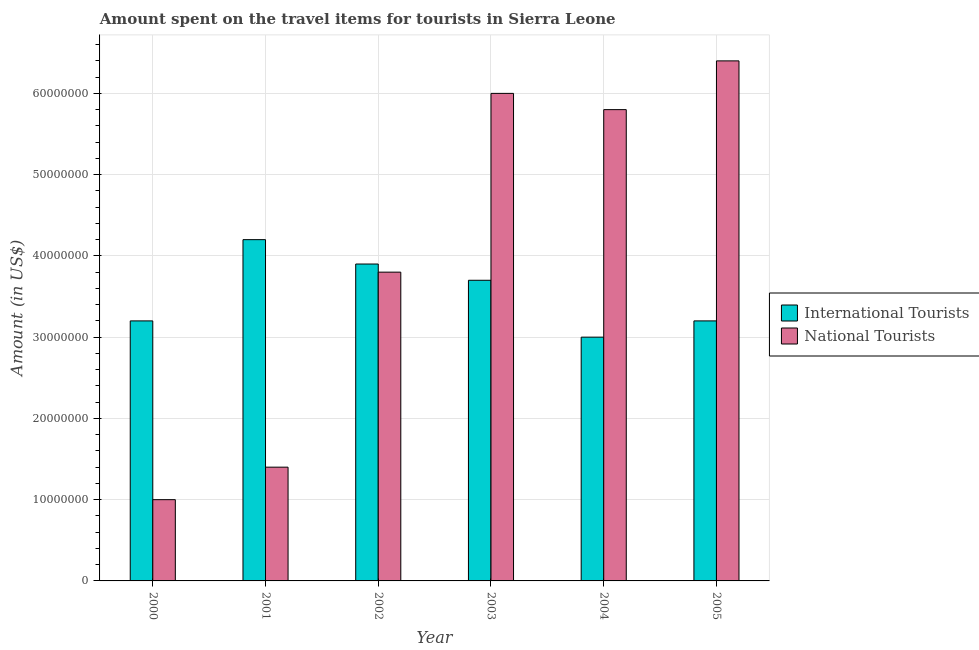Are the number of bars per tick equal to the number of legend labels?
Make the answer very short. Yes. How many bars are there on the 4th tick from the right?
Your answer should be compact. 2. What is the label of the 4th group of bars from the left?
Provide a succinct answer. 2003. What is the amount spent on travel items of national tourists in 2002?
Your answer should be very brief. 3.80e+07. Across all years, what is the maximum amount spent on travel items of international tourists?
Provide a short and direct response. 4.20e+07. Across all years, what is the minimum amount spent on travel items of international tourists?
Your answer should be very brief. 3.00e+07. In which year was the amount spent on travel items of national tourists maximum?
Provide a succinct answer. 2005. What is the total amount spent on travel items of international tourists in the graph?
Ensure brevity in your answer.  2.12e+08. What is the difference between the amount spent on travel items of national tourists in 2003 and that in 2005?
Offer a very short reply. -4.00e+06. What is the difference between the amount spent on travel items of national tourists in 2003 and the amount spent on travel items of international tourists in 2005?
Your response must be concise. -4.00e+06. What is the average amount spent on travel items of national tourists per year?
Offer a terse response. 4.07e+07. In how many years, is the amount spent on travel items of national tourists greater than 6000000 US$?
Provide a short and direct response. 6. What is the ratio of the amount spent on travel items of national tourists in 2001 to that in 2002?
Your response must be concise. 0.37. Is the amount spent on travel items of national tourists in 2003 less than that in 2004?
Offer a terse response. No. Is the difference between the amount spent on travel items of international tourists in 2000 and 2002 greater than the difference between the amount spent on travel items of national tourists in 2000 and 2002?
Ensure brevity in your answer.  No. What is the difference between the highest and the lowest amount spent on travel items of international tourists?
Offer a very short reply. 1.20e+07. In how many years, is the amount spent on travel items of international tourists greater than the average amount spent on travel items of international tourists taken over all years?
Give a very brief answer. 3. What does the 2nd bar from the left in 2003 represents?
Your response must be concise. National Tourists. What does the 1st bar from the right in 2001 represents?
Your answer should be very brief. National Tourists. How many bars are there?
Offer a very short reply. 12. Are all the bars in the graph horizontal?
Your answer should be compact. No. How many years are there in the graph?
Your answer should be compact. 6. What is the difference between two consecutive major ticks on the Y-axis?
Give a very brief answer. 1.00e+07. Are the values on the major ticks of Y-axis written in scientific E-notation?
Your answer should be very brief. No. Where does the legend appear in the graph?
Provide a succinct answer. Center right. How many legend labels are there?
Your answer should be compact. 2. What is the title of the graph?
Make the answer very short. Amount spent on the travel items for tourists in Sierra Leone. What is the Amount (in US$) of International Tourists in 2000?
Give a very brief answer. 3.20e+07. What is the Amount (in US$) of National Tourists in 2000?
Your answer should be compact. 1.00e+07. What is the Amount (in US$) in International Tourists in 2001?
Give a very brief answer. 4.20e+07. What is the Amount (in US$) in National Tourists in 2001?
Give a very brief answer. 1.40e+07. What is the Amount (in US$) of International Tourists in 2002?
Provide a succinct answer. 3.90e+07. What is the Amount (in US$) of National Tourists in 2002?
Ensure brevity in your answer.  3.80e+07. What is the Amount (in US$) in International Tourists in 2003?
Provide a succinct answer. 3.70e+07. What is the Amount (in US$) in National Tourists in 2003?
Your answer should be very brief. 6.00e+07. What is the Amount (in US$) in International Tourists in 2004?
Your answer should be compact. 3.00e+07. What is the Amount (in US$) in National Tourists in 2004?
Ensure brevity in your answer.  5.80e+07. What is the Amount (in US$) in International Tourists in 2005?
Give a very brief answer. 3.20e+07. What is the Amount (in US$) of National Tourists in 2005?
Your response must be concise. 6.40e+07. Across all years, what is the maximum Amount (in US$) of International Tourists?
Offer a terse response. 4.20e+07. Across all years, what is the maximum Amount (in US$) in National Tourists?
Provide a short and direct response. 6.40e+07. Across all years, what is the minimum Amount (in US$) of International Tourists?
Offer a terse response. 3.00e+07. Across all years, what is the minimum Amount (in US$) of National Tourists?
Ensure brevity in your answer.  1.00e+07. What is the total Amount (in US$) of International Tourists in the graph?
Your answer should be very brief. 2.12e+08. What is the total Amount (in US$) of National Tourists in the graph?
Provide a succinct answer. 2.44e+08. What is the difference between the Amount (in US$) of International Tourists in 2000 and that in 2001?
Your answer should be compact. -1.00e+07. What is the difference between the Amount (in US$) of International Tourists in 2000 and that in 2002?
Your answer should be compact. -7.00e+06. What is the difference between the Amount (in US$) in National Tourists in 2000 and that in 2002?
Ensure brevity in your answer.  -2.80e+07. What is the difference between the Amount (in US$) in International Tourists in 2000 and that in 2003?
Your answer should be very brief. -5.00e+06. What is the difference between the Amount (in US$) in National Tourists in 2000 and that in 2003?
Ensure brevity in your answer.  -5.00e+07. What is the difference between the Amount (in US$) in International Tourists in 2000 and that in 2004?
Your response must be concise. 2.00e+06. What is the difference between the Amount (in US$) of National Tourists in 2000 and that in 2004?
Give a very brief answer. -4.80e+07. What is the difference between the Amount (in US$) in National Tourists in 2000 and that in 2005?
Ensure brevity in your answer.  -5.40e+07. What is the difference between the Amount (in US$) of National Tourists in 2001 and that in 2002?
Give a very brief answer. -2.40e+07. What is the difference between the Amount (in US$) of International Tourists in 2001 and that in 2003?
Make the answer very short. 5.00e+06. What is the difference between the Amount (in US$) in National Tourists in 2001 and that in 2003?
Offer a terse response. -4.60e+07. What is the difference between the Amount (in US$) in International Tourists in 2001 and that in 2004?
Provide a short and direct response. 1.20e+07. What is the difference between the Amount (in US$) in National Tourists in 2001 and that in 2004?
Ensure brevity in your answer.  -4.40e+07. What is the difference between the Amount (in US$) of National Tourists in 2001 and that in 2005?
Offer a very short reply. -5.00e+07. What is the difference between the Amount (in US$) of National Tourists in 2002 and that in 2003?
Provide a short and direct response. -2.20e+07. What is the difference between the Amount (in US$) of International Tourists in 2002 and that in 2004?
Offer a very short reply. 9.00e+06. What is the difference between the Amount (in US$) of National Tourists in 2002 and that in 2004?
Provide a short and direct response. -2.00e+07. What is the difference between the Amount (in US$) in International Tourists in 2002 and that in 2005?
Offer a terse response. 7.00e+06. What is the difference between the Amount (in US$) of National Tourists in 2002 and that in 2005?
Provide a short and direct response. -2.60e+07. What is the difference between the Amount (in US$) in International Tourists in 2003 and that in 2004?
Give a very brief answer. 7.00e+06. What is the difference between the Amount (in US$) of National Tourists in 2003 and that in 2004?
Provide a short and direct response. 2.00e+06. What is the difference between the Amount (in US$) of International Tourists in 2004 and that in 2005?
Provide a succinct answer. -2.00e+06. What is the difference between the Amount (in US$) in National Tourists in 2004 and that in 2005?
Provide a succinct answer. -6.00e+06. What is the difference between the Amount (in US$) in International Tourists in 2000 and the Amount (in US$) in National Tourists in 2001?
Your answer should be very brief. 1.80e+07. What is the difference between the Amount (in US$) in International Tourists in 2000 and the Amount (in US$) in National Tourists in 2002?
Your answer should be very brief. -6.00e+06. What is the difference between the Amount (in US$) in International Tourists in 2000 and the Amount (in US$) in National Tourists in 2003?
Ensure brevity in your answer.  -2.80e+07. What is the difference between the Amount (in US$) in International Tourists in 2000 and the Amount (in US$) in National Tourists in 2004?
Provide a short and direct response. -2.60e+07. What is the difference between the Amount (in US$) of International Tourists in 2000 and the Amount (in US$) of National Tourists in 2005?
Provide a short and direct response. -3.20e+07. What is the difference between the Amount (in US$) in International Tourists in 2001 and the Amount (in US$) in National Tourists in 2002?
Offer a terse response. 4.00e+06. What is the difference between the Amount (in US$) of International Tourists in 2001 and the Amount (in US$) of National Tourists in 2003?
Your response must be concise. -1.80e+07. What is the difference between the Amount (in US$) of International Tourists in 2001 and the Amount (in US$) of National Tourists in 2004?
Make the answer very short. -1.60e+07. What is the difference between the Amount (in US$) in International Tourists in 2001 and the Amount (in US$) in National Tourists in 2005?
Provide a short and direct response. -2.20e+07. What is the difference between the Amount (in US$) of International Tourists in 2002 and the Amount (in US$) of National Tourists in 2003?
Ensure brevity in your answer.  -2.10e+07. What is the difference between the Amount (in US$) in International Tourists in 2002 and the Amount (in US$) in National Tourists in 2004?
Provide a succinct answer. -1.90e+07. What is the difference between the Amount (in US$) in International Tourists in 2002 and the Amount (in US$) in National Tourists in 2005?
Your response must be concise. -2.50e+07. What is the difference between the Amount (in US$) in International Tourists in 2003 and the Amount (in US$) in National Tourists in 2004?
Ensure brevity in your answer.  -2.10e+07. What is the difference between the Amount (in US$) of International Tourists in 2003 and the Amount (in US$) of National Tourists in 2005?
Give a very brief answer. -2.70e+07. What is the difference between the Amount (in US$) in International Tourists in 2004 and the Amount (in US$) in National Tourists in 2005?
Provide a succinct answer. -3.40e+07. What is the average Amount (in US$) of International Tourists per year?
Provide a short and direct response. 3.53e+07. What is the average Amount (in US$) of National Tourists per year?
Ensure brevity in your answer.  4.07e+07. In the year 2000, what is the difference between the Amount (in US$) in International Tourists and Amount (in US$) in National Tourists?
Offer a very short reply. 2.20e+07. In the year 2001, what is the difference between the Amount (in US$) in International Tourists and Amount (in US$) in National Tourists?
Your response must be concise. 2.80e+07. In the year 2002, what is the difference between the Amount (in US$) of International Tourists and Amount (in US$) of National Tourists?
Your answer should be compact. 1.00e+06. In the year 2003, what is the difference between the Amount (in US$) in International Tourists and Amount (in US$) in National Tourists?
Your answer should be very brief. -2.30e+07. In the year 2004, what is the difference between the Amount (in US$) of International Tourists and Amount (in US$) of National Tourists?
Give a very brief answer. -2.80e+07. In the year 2005, what is the difference between the Amount (in US$) of International Tourists and Amount (in US$) of National Tourists?
Provide a short and direct response. -3.20e+07. What is the ratio of the Amount (in US$) in International Tourists in 2000 to that in 2001?
Provide a short and direct response. 0.76. What is the ratio of the Amount (in US$) in National Tourists in 2000 to that in 2001?
Provide a short and direct response. 0.71. What is the ratio of the Amount (in US$) of International Tourists in 2000 to that in 2002?
Your response must be concise. 0.82. What is the ratio of the Amount (in US$) in National Tourists in 2000 to that in 2002?
Give a very brief answer. 0.26. What is the ratio of the Amount (in US$) in International Tourists in 2000 to that in 2003?
Offer a very short reply. 0.86. What is the ratio of the Amount (in US$) of International Tourists in 2000 to that in 2004?
Your answer should be compact. 1.07. What is the ratio of the Amount (in US$) in National Tourists in 2000 to that in 2004?
Your answer should be very brief. 0.17. What is the ratio of the Amount (in US$) in National Tourists in 2000 to that in 2005?
Your answer should be compact. 0.16. What is the ratio of the Amount (in US$) in International Tourists in 2001 to that in 2002?
Your answer should be very brief. 1.08. What is the ratio of the Amount (in US$) of National Tourists in 2001 to that in 2002?
Provide a succinct answer. 0.37. What is the ratio of the Amount (in US$) of International Tourists in 2001 to that in 2003?
Offer a terse response. 1.14. What is the ratio of the Amount (in US$) in National Tourists in 2001 to that in 2003?
Ensure brevity in your answer.  0.23. What is the ratio of the Amount (in US$) of National Tourists in 2001 to that in 2004?
Your response must be concise. 0.24. What is the ratio of the Amount (in US$) of International Tourists in 2001 to that in 2005?
Give a very brief answer. 1.31. What is the ratio of the Amount (in US$) in National Tourists in 2001 to that in 2005?
Your answer should be very brief. 0.22. What is the ratio of the Amount (in US$) of International Tourists in 2002 to that in 2003?
Give a very brief answer. 1.05. What is the ratio of the Amount (in US$) in National Tourists in 2002 to that in 2003?
Ensure brevity in your answer.  0.63. What is the ratio of the Amount (in US$) of International Tourists in 2002 to that in 2004?
Provide a succinct answer. 1.3. What is the ratio of the Amount (in US$) of National Tourists in 2002 to that in 2004?
Give a very brief answer. 0.66. What is the ratio of the Amount (in US$) of International Tourists in 2002 to that in 2005?
Keep it short and to the point. 1.22. What is the ratio of the Amount (in US$) of National Tourists in 2002 to that in 2005?
Your answer should be compact. 0.59. What is the ratio of the Amount (in US$) of International Tourists in 2003 to that in 2004?
Provide a short and direct response. 1.23. What is the ratio of the Amount (in US$) of National Tourists in 2003 to that in 2004?
Provide a succinct answer. 1.03. What is the ratio of the Amount (in US$) in International Tourists in 2003 to that in 2005?
Your answer should be very brief. 1.16. What is the ratio of the Amount (in US$) of National Tourists in 2004 to that in 2005?
Your response must be concise. 0.91. What is the difference between the highest and the second highest Amount (in US$) in National Tourists?
Provide a short and direct response. 4.00e+06. What is the difference between the highest and the lowest Amount (in US$) of International Tourists?
Offer a terse response. 1.20e+07. What is the difference between the highest and the lowest Amount (in US$) in National Tourists?
Offer a terse response. 5.40e+07. 